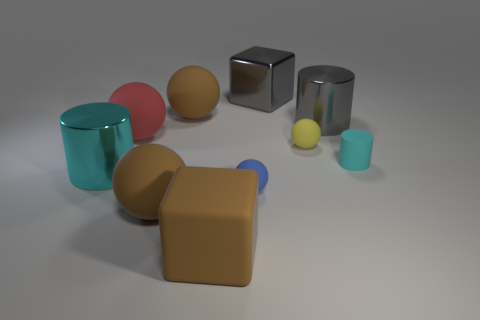What material is the blue object that is the same shape as the red matte thing?
Keep it short and to the point. Rubber. Do the metallic object that is on the left side of the blue sphere and the brown rubber object that is behind the red matte thing have the same shape?
Your response must be concise. No. Are there more shiny balls than red matte things?
Keep it short and to the point. No. What size is the cyan rubber cylinder?
Keep it short and to the point. Small. How many other objects are there of the same color as the metallic block?
Ensure brevity in your answer.  1. Are the cylinder that is on the left side of the big rubber cube and the blue sphere made of the same material?
Offer a terse response. No. Are there fewer large gray metallic blocks to the left of the small blue thing than shiny things right of the small yellow object?
Provide a succinct answer. Yes. How many other objects are the same material as the big gray cube?
Offer a terse response. 2. There is a cyan cylinder that is the same size as the red matte ball; what is it made of?
Provide a succinct answer. Metal. Is the number of large brown balls that are on the right side of the gray metal cylinder less than the number of gray metallic cubes?
Your answer should be very brief. Yes. 